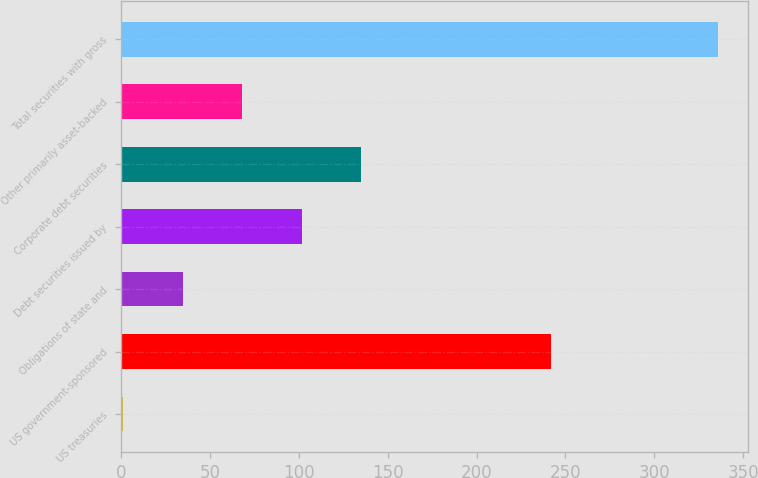Convert chart. <chart><loc_0><loc_0><loc_500><loc_500><bar_chart><fcel>US treasuries<fcel>US government-sponsored<fcel>Obligations of state and<fcel>Debt securities issued by<fcel>Corporate debt securities<fcel>Other primarily asset-backed<fcel>Total securities with gross<nl><fcel>1<fcel>242<fcel>34.5<fcel>101.5<fcel>135<fcel>68<fcel>336<nl></chart> 